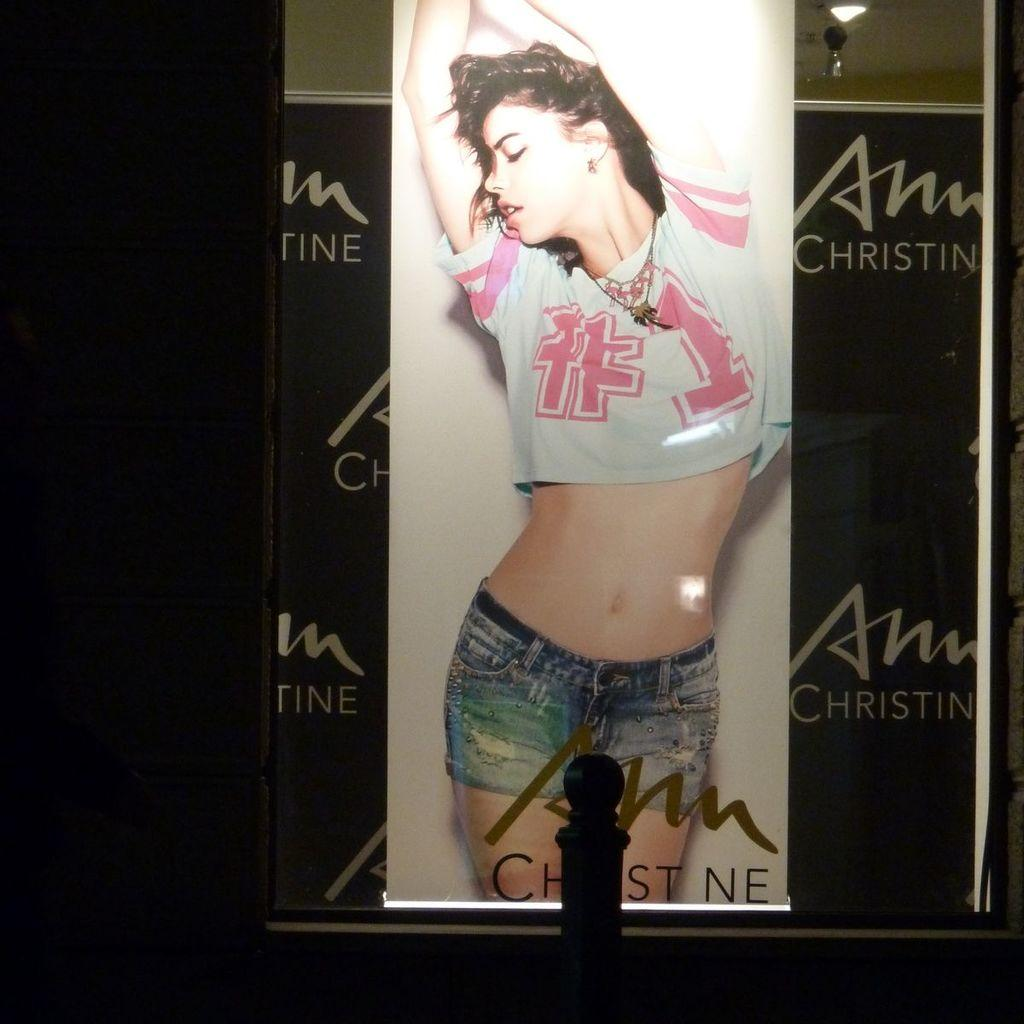<image>
Relay a brief, clear account of the picture shown. Poster showing a woman wearing a shirt which says #1. 